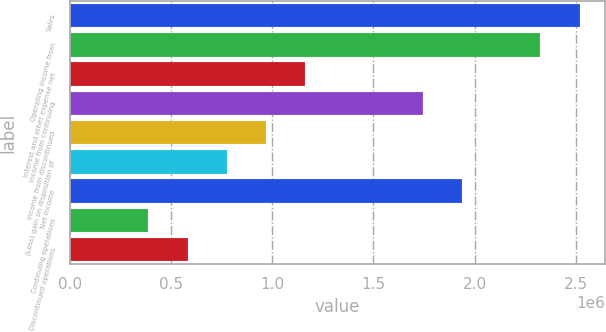<chart> <loc_0><loc_0><loc_500><loc_500><bar_chart><fcel>Sales<fcel>Operating income from<fcel>Interest and other expense net<fcel>Income from continuing<fcel>Income from discontinued<fcel>(Loss) gain on disposition of<fcel>Net income<fcel>Continuing operations<fcel>Discontinued operations<nl><fcel>2.5187e+06<fcel>2.32496e+06<fcel>1.16248e+06<fcel>1.74372e+06<fcel>968733<fcel>774986<fcel>1.93746e+06<fcel>387493<fcel>581240<nl></chart> 